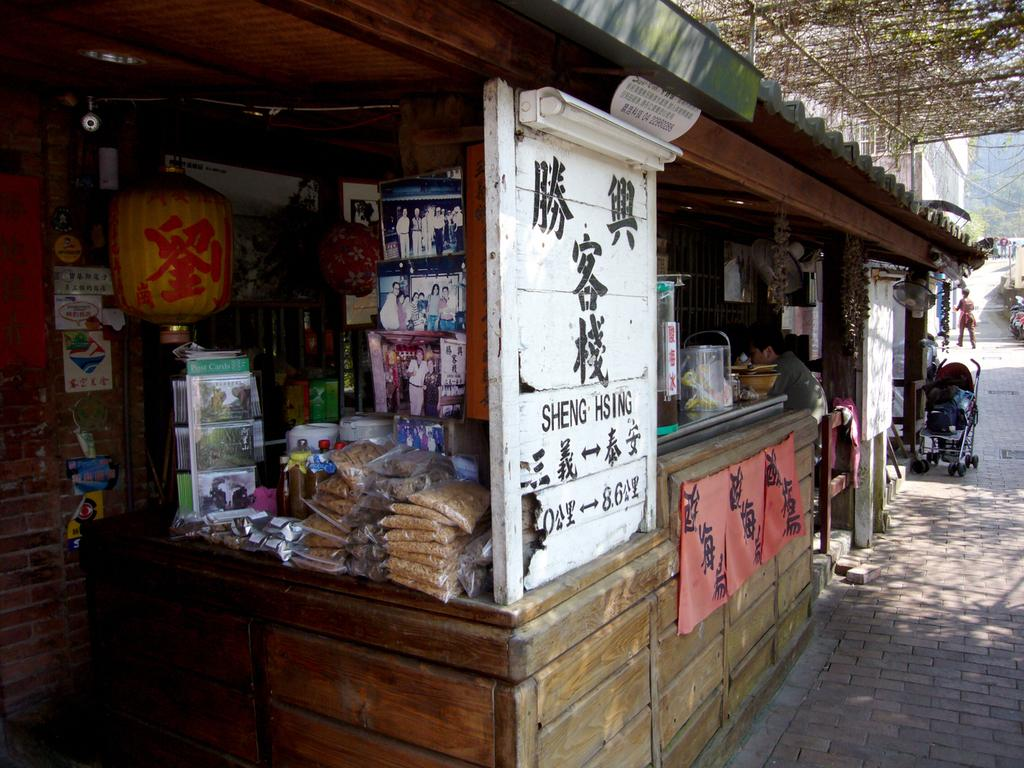What is the main subject in the center of the image? There is a store in the center of the image. Can you describe the person in the image? There is a person sitting on a chair in the image. What is visible at the bottom of the image? There is a road at the bottom of the image. What is the tax rate for the store in the image? There is no information about the tax rate for the store in the image. 